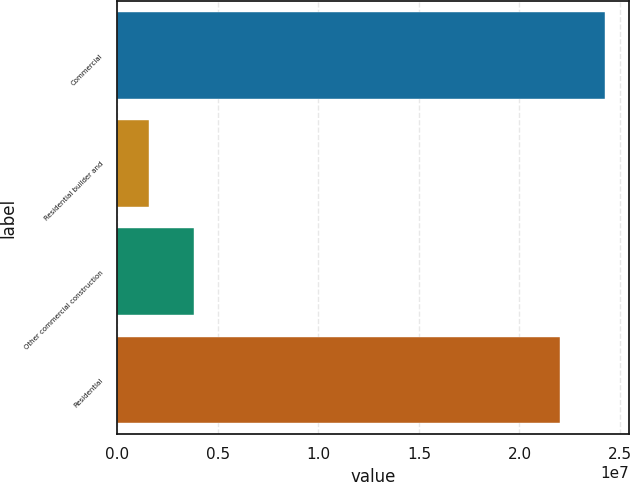Convert chart. <chart><loc_0><loc_0><loc_500><loc_500><bar_chart><fcel>Commercial<fcel>Residential builder and<fcel>Other commercial construction<fcel>Residential<nl><fcel>2.42583e+07<fcel>1.58567e+06<fcel>3.8337e+06<fcel>2.20103e+07<nl></chart> 